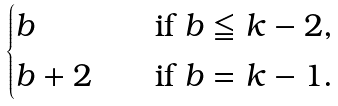<formula> <loc_0><loc_0><loc_500><loc_500>\begin{cases} b \quad & \text {if $b\leqq k-2$,} \\ b + 2 \quad & \text {if $b=k-1$} . \end{cases}</formula> 